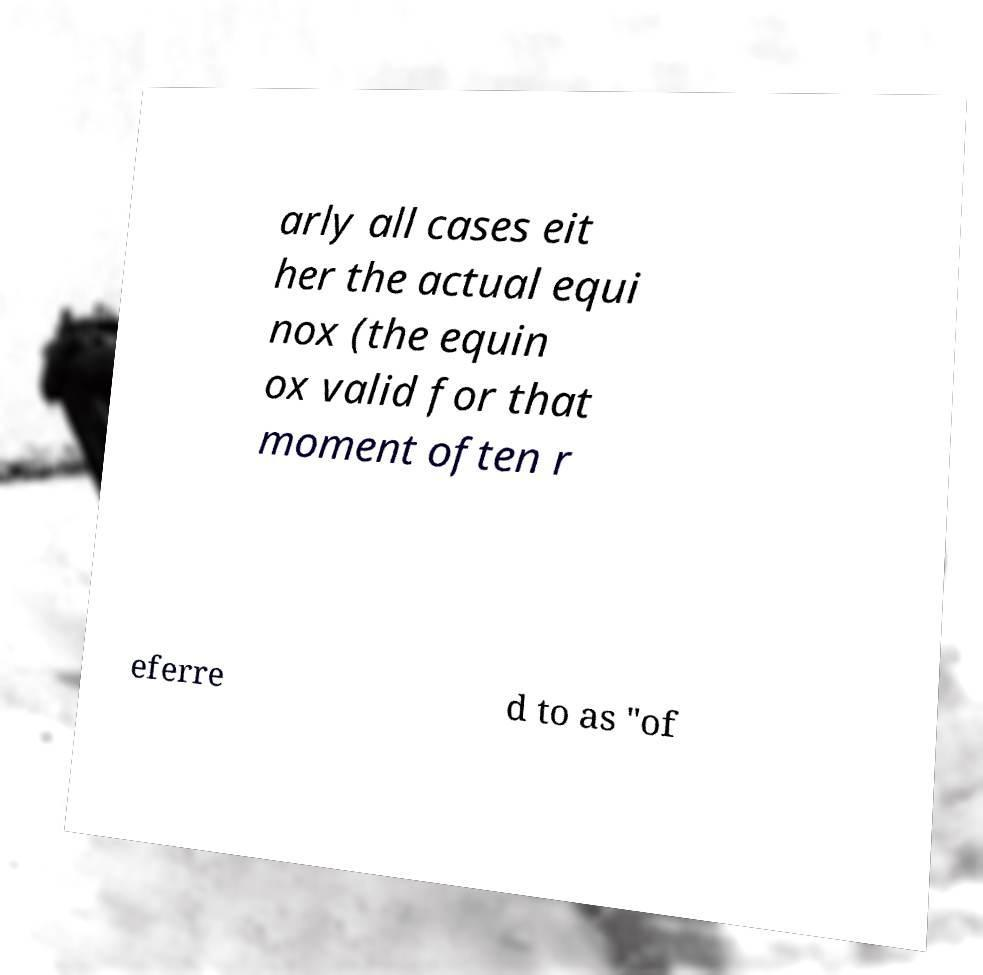I need the written content from this picture converted into text. Can you do that? arly all cases eit her the actual equi nox (the equin ox valid for that moment often r eferre d to as "of 